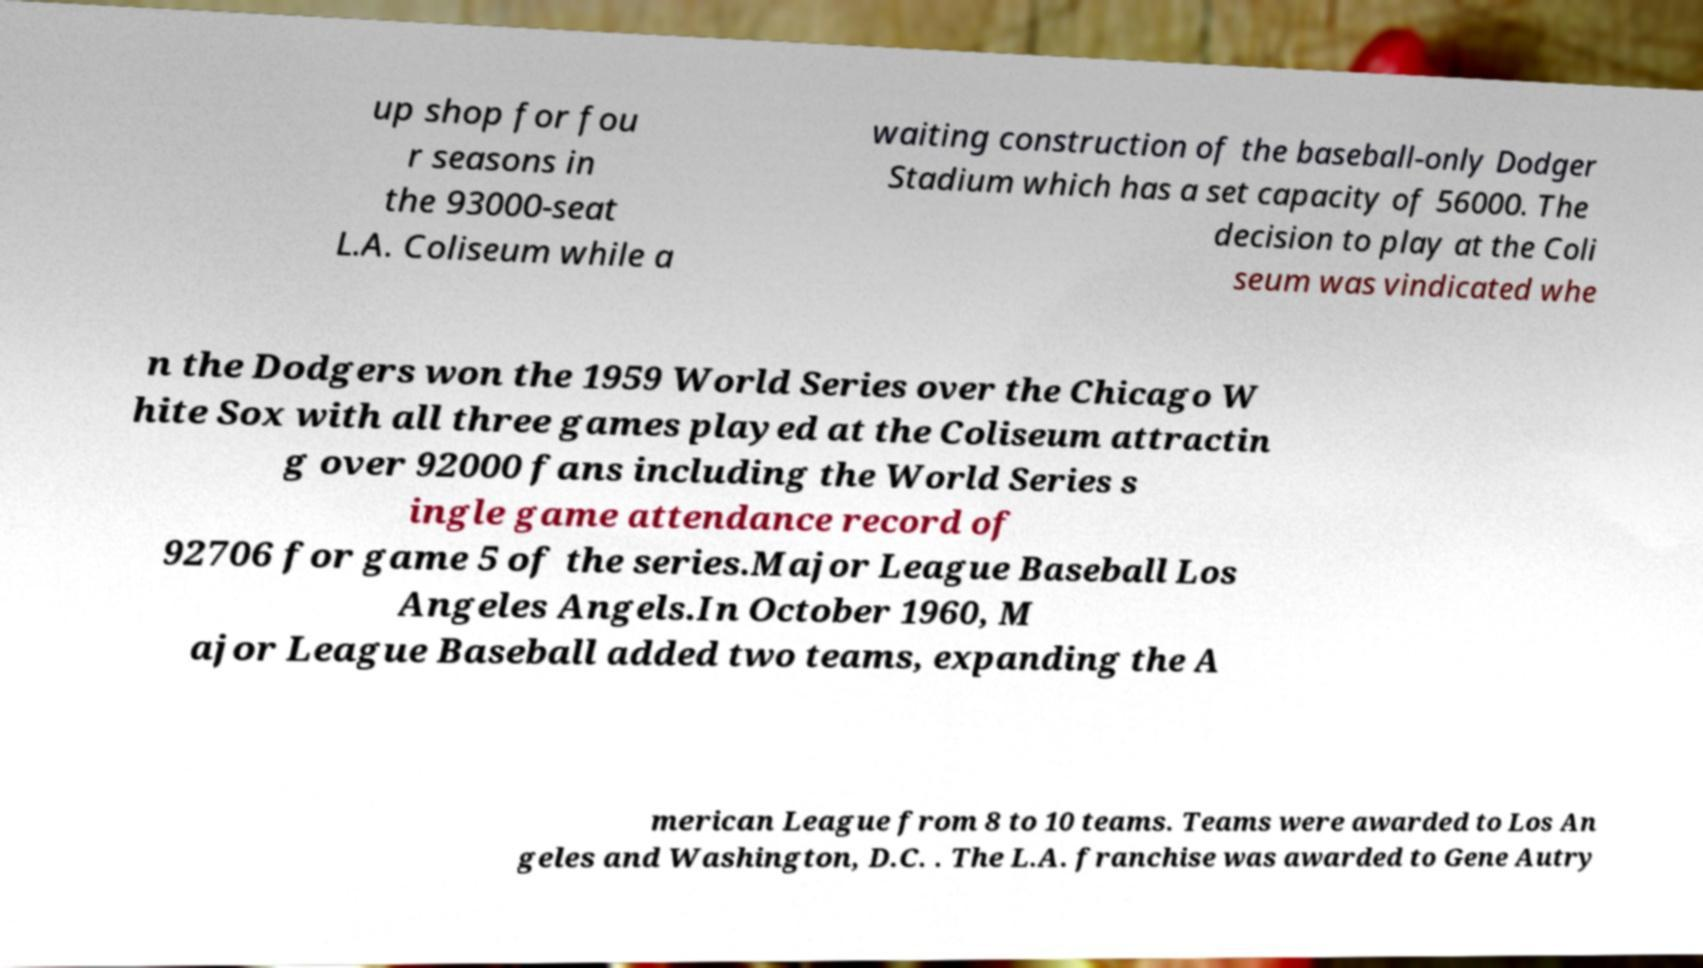There's text embedded in this image that I need extracted. Can you transcribe it verbatim? up shop for fou r seasons in the 93000-seat L.A. Coliseum while a waiting construction of the baseball-only Dodger Stadium which has a set capacity of 56000. The decision to play at the Coli seum was vindicated whe n the Dodgers won the 1959 World Series over the Chicago W hite Sox with all three games played at the Coliseum attractin g over 92000 fans including the World Series s ingle game attendance record of 92706 for game 5 of the series.Major League Baseball Los Angeles Angels.In October 1960, M ajor League Baseball added two teams, expanding the A merican League from 8 to 10 teams. Teams were awarded to Los An geles and Washington, D.C. . The L.A. franchise was awarded to Gene Autry 